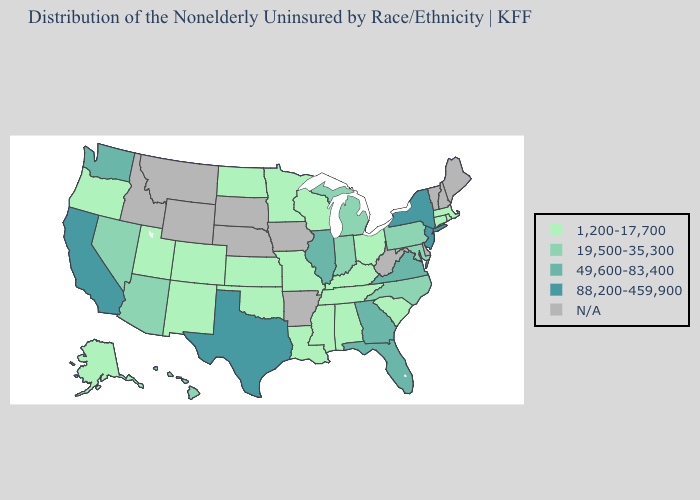Is the legend a continuous bar?
Write a very short answer. No. What is the highest value in states that border West Virginia?
Answer briefly. 49,600-83,400. What is the highest value in the USA?
Concise answer only. 88,200-459,900. Does the map have missing data?
Be succinct. Yes. What is the highest value in the Northeast ?
Keep it brief. 88,200-459,900. What is the value of New Mexico?
Keep it brief. 1,200-17,700. What is the value of Texas?
Write a very short answer. 88,200-459,900. What is the highest value in the USA?
Concise answer only. 88,200-459,900. What is the value of Alabama?
Quick response, please. 1,200-17,700. Name the states that have a value in the range 19,500-35,300?
Short answer required. Arizona, Hawaii, Indiana, Maryland, Michigan, Nevada, North Carolina, Pennsylvania. What is the value of Hawaii?
Answer briefly. 19,500-35,300. Name the states that have a value in the range 19,500-35,300?
Be succinct. Arizona, Hawaii, Indiana, Maryland, Michigan, Nevada, North Carolina, Pennsylvania. Does the first symbol in the legend represent the smallest category?
Give a very brief answer. Yes. What is the value of South Carolina?
Concise answer only. 1,200-17,700. What is the value of Nebraska?
Be succinct. N/A. 